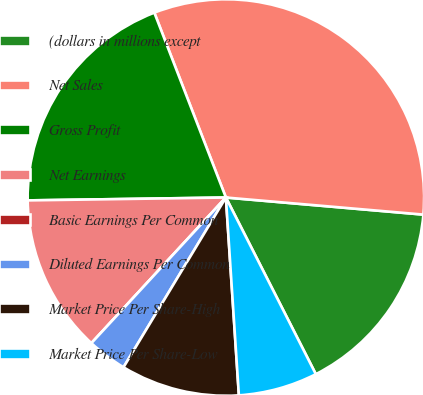Convert chart. <chart><loc_0><loc_0><loc_500><loc_500><pie_chart><fcel>(dollars in millions except<fcel>Net Sales<fcel>Gross Profit<fcel>Net Earnings<fcel>Basic Earnings Per Common<fcel>Diluted Earnings Per Common<fcel>Market Price Per Share-High<fcel>Market Price Per Share-Low<nl><fcel>16.13%<fcel>32.25%<fcel>19.35%<fcel>12.9%<fcel>0.0%<fcel>3.23%<fcel>9.68%<fcel>6.45%<nl></chart> 